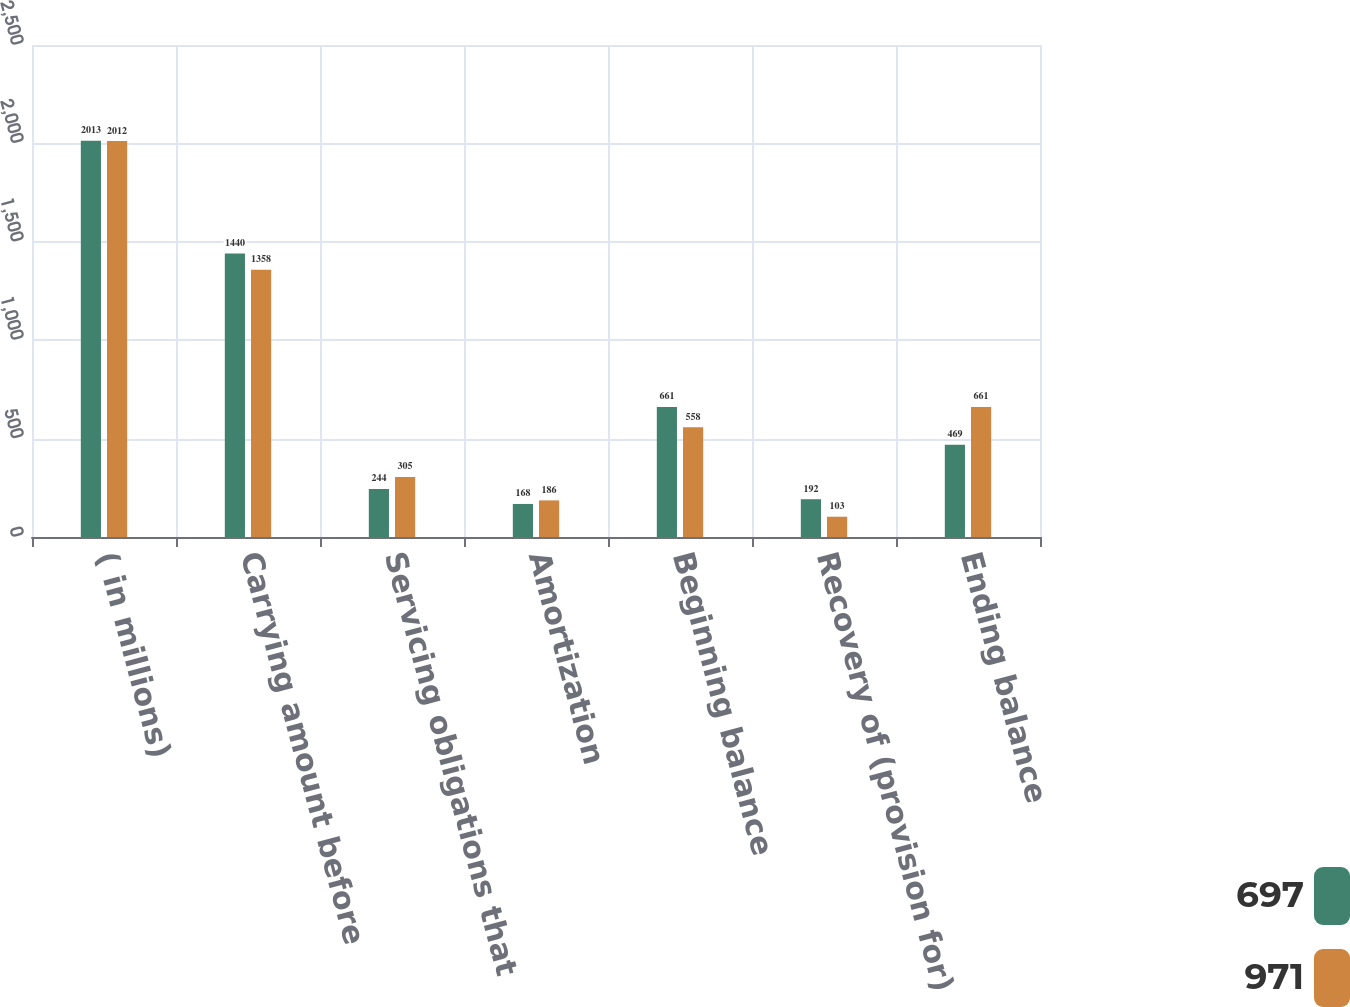Convert chart. <chart><loc_0><loc_0><loc_500><loc_500><stacked_bar_chart><ecel><fcel>( in millions)<fcel>Carrying amount before<fcel>Servicing obligations that<fcel>Amortization<fcel>Beginning balance<fcel>Recovery of (provision for)<fcel>Ending balance<nl><fcel>697<fcel>2013<fcel>1440<fcel>244<fcel>168<fcel>661<fcel>192<fcel>469<nl><fcel>971<fcel>2012<fcel>1358<fcel>305<fcel>186<fcel>558<fcel>103<fcel>661<nl></chart> 